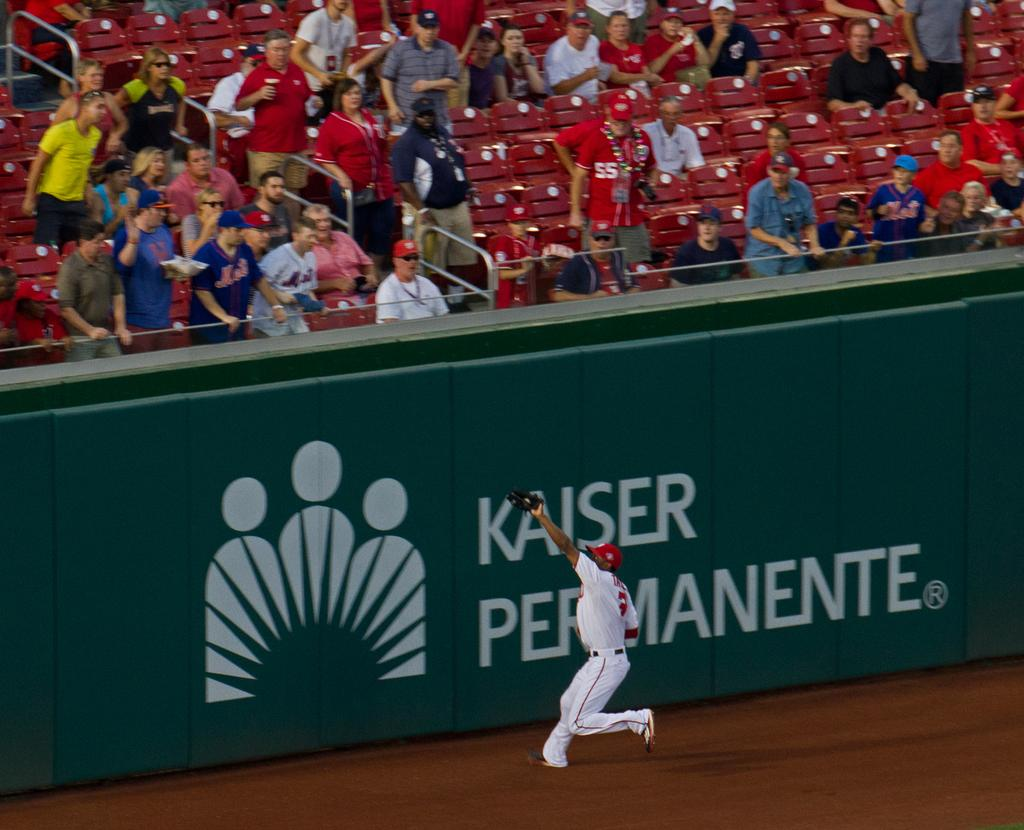<image>
Write a terse but informative summary of the picture. Man about to catch a ball in front of an ad that says "Kaiser Permanente". 